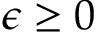<formula> <loc_0><loc_0><loc_500><loc_500>\epsilon \geq 0</formula> 